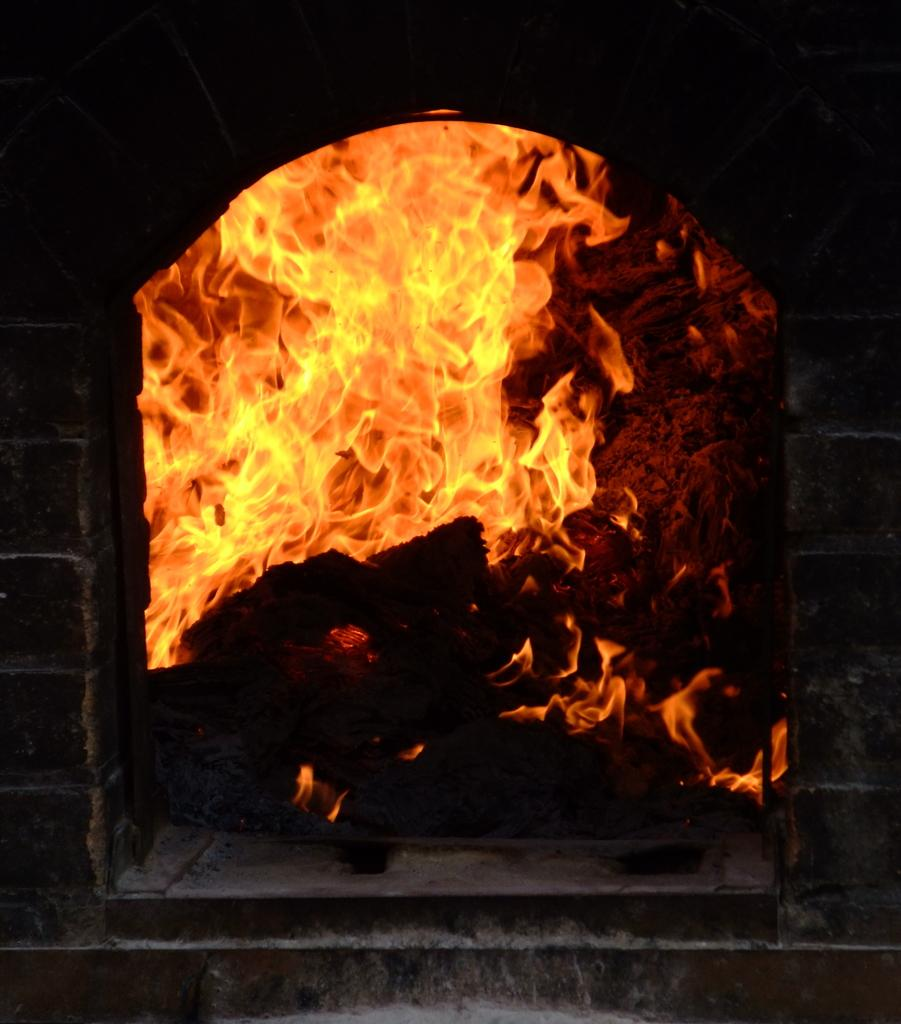What is the primary element visible in the image? There is a flame in the image. What type of insurance policy is required for the unit in the image? There is no unit or insurance policy mentioned in the image; it only features a flame. 